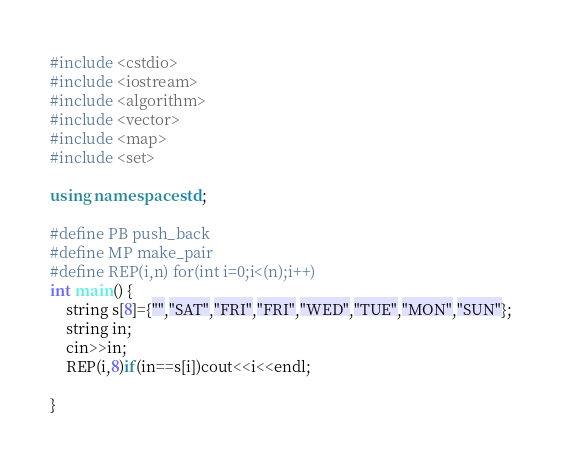<code> <loc_0><loc_0><loc_500><loc_500><_C++_>#include <cstdio>
#include <iostream>
#include <algorithm>
#include <vector>
#include <map>
#include <set>
 
using namespace std;
 
#define PB push_back
#define MP make_pair
#define REP(i,n) for(int i=0;i<(n);i++)
int main() {
    string s[8]={"","SAT","FRI","FRI","WED","TUE","MON","SUN"};
    string in;
    cin>>in;
    REP(i,8)if(in==s[i])cout<<i<<endl;

}</code> 